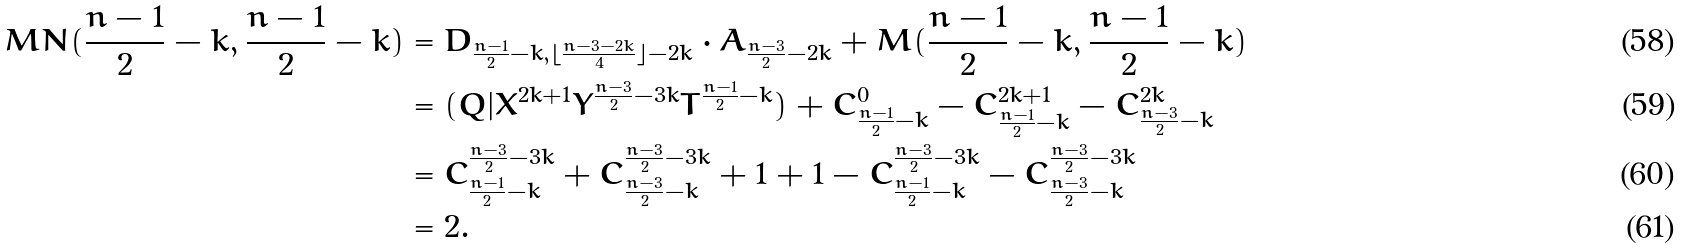<formula> <loc_0><loc_0><loc_500><loc_500>M N ( \frac { n - 1 } { 2 } - k , \frac { n - 1 } { 2 } - k ) & = D _ { \frac { n - 1 } { 2 } - k , \lfloor \frac { n - 3 - 2 k } { 4 } \rfloor - 2 k } \cdot A _ { \frac { n - 3 } { 2 } - 2 k } + M ( \frac { n - 1 } { 2 } - k , \frac { n - 1 } { 2 } - k ) \\ & = ( Q | X ^ { 2 k + 1 } Y ^ { \frac { n - 3 } { 2 } - 3 k } T ^ { \frac { n - 1 } { 2 } - k } ) + C _ { \frac { n - 1 } { 2 } - k } ^ { 0 } - C _ { \frac { n - 1 } { 2 } - k } ^ { 2 k + 1 } - C _ { \frac { n - 3 } { 2 } - k } ^ { 2 k } \\ & = C _ { \frac { n - 1 } { 2 } - k } ^ { \frac { n - 3 } { 2 } - 3 k } + C _ { \frac { n - 3 } { 2 } - k } ^ { \frac { n - 3 } { 2 } - 3 k } + 1 + 1 - C _ { \frac { n - 1 } { 2 } - k } ^ { \frac { n - 3 } { 2 } - 3 k } - C _ { \frac { n - 3 } { 2 } - k } ^ { \frac { n - 3 } { 2 } - 3 k } \\ & = 2 .</formula> 